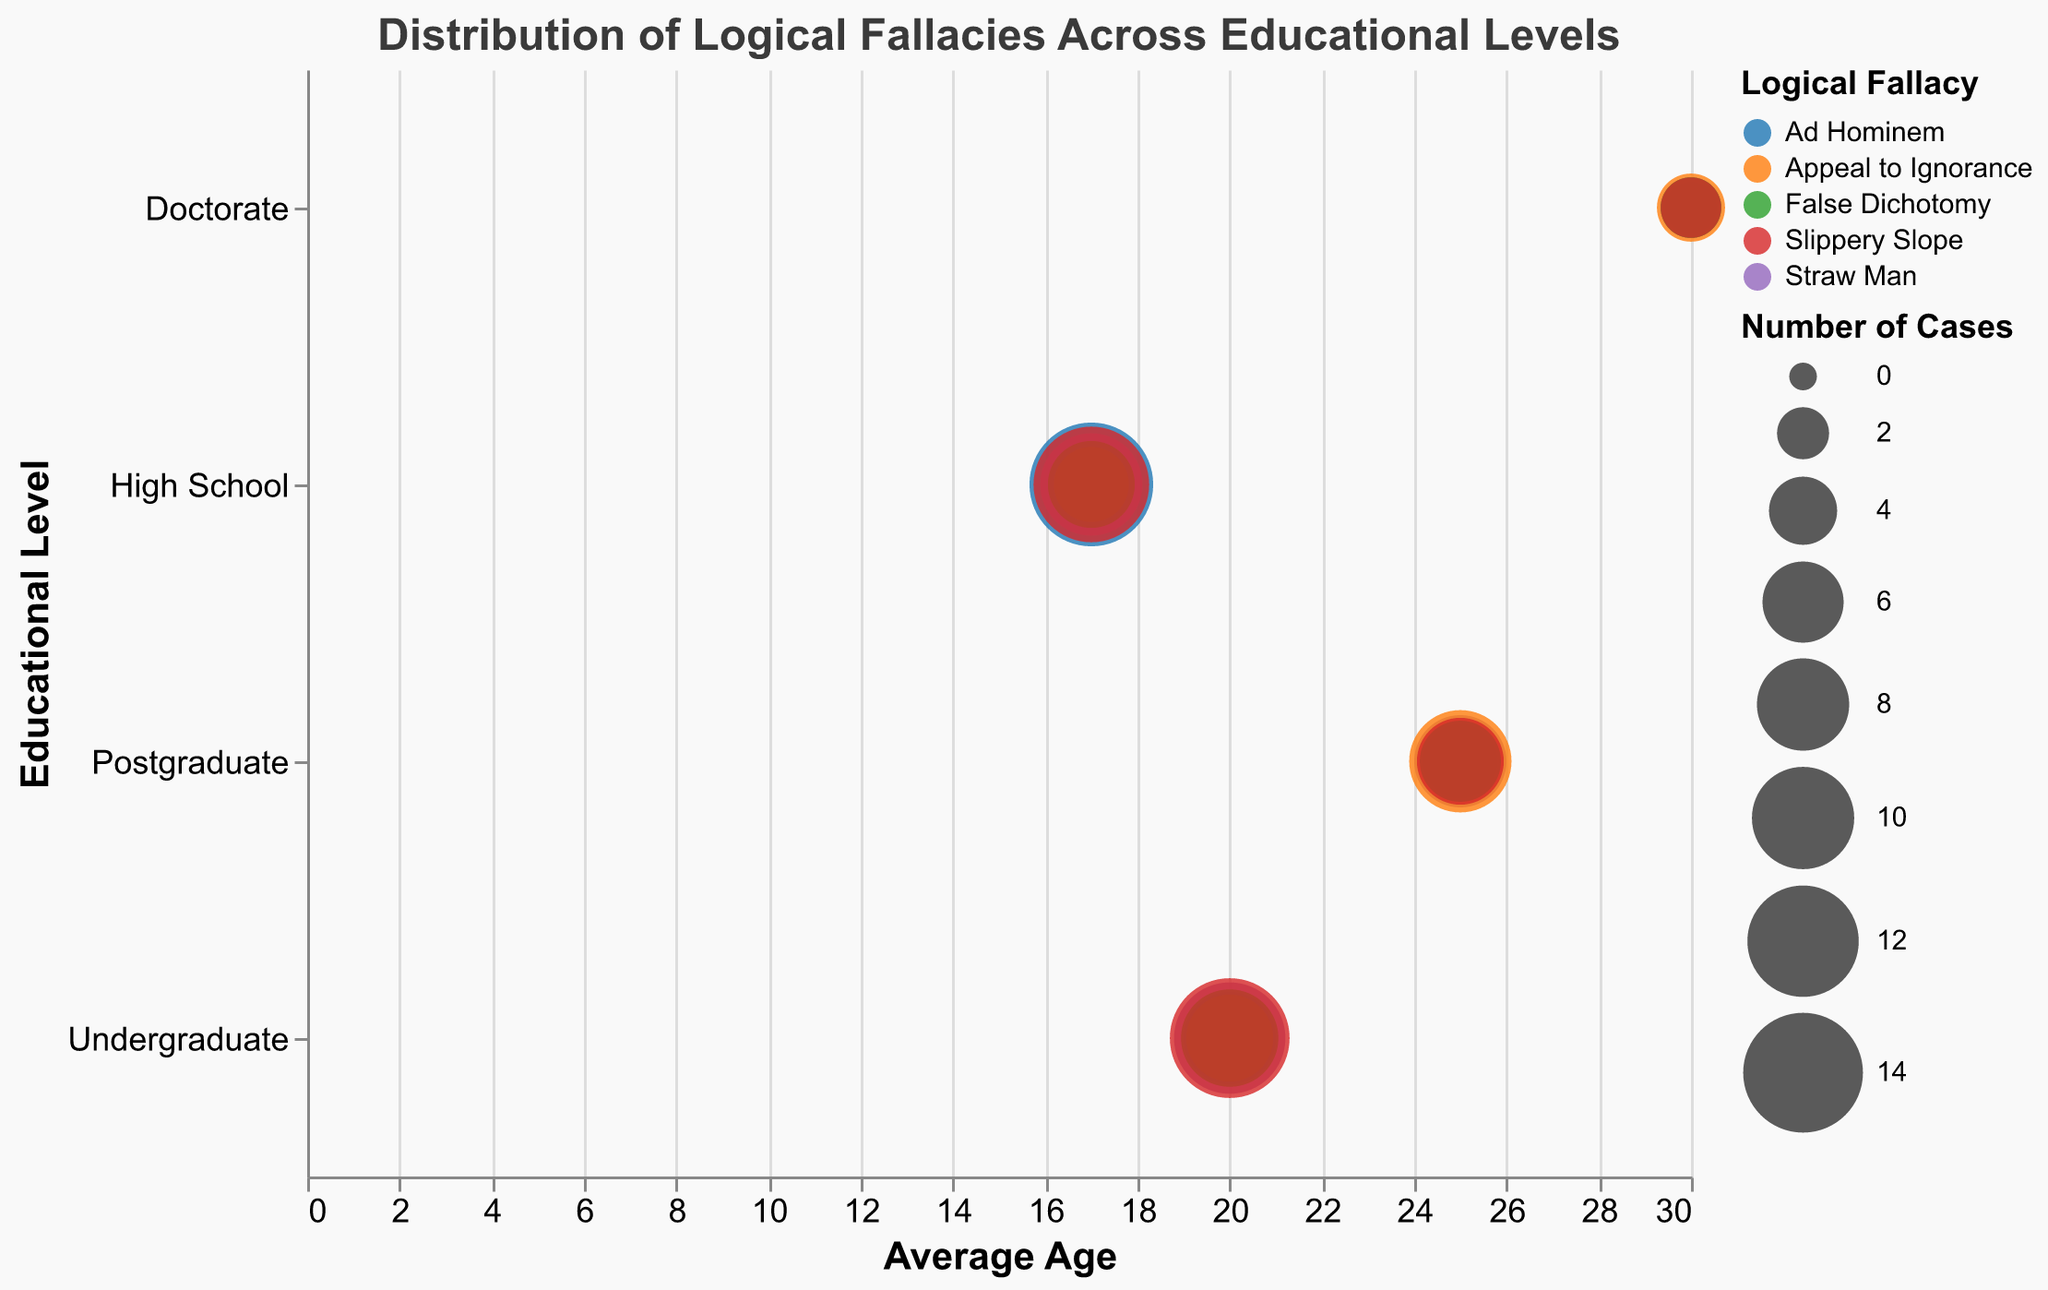What is the average age of individuals in the "Undergraduate" educational level category? The x-axis represents the average age. For the "Undergraduate" category, this is marked as 20.
Answer: 20 Which logical fallacy has the highest number of cases in the "High School" educational level? The size of the bubbles represents the number of cases, and bigger bubbles indicate a higher number. For the "High School" level, the largest bubble corresponds to the "Ad Hominem" fallacy with 15 cases.
Answer: Ad Hominem Compare the total number of cases of "False Dichotomy" and "Slippery Slope" fallacies across all educational levels. Which has more cases? Summing up the number of cases for each.
- False Dichotomy: 7(HS) + 9(UG) + 6(PG) + 3(D) = 25 
- Slippery Slope: 13(HS) + 14(UG) + 7(PG) + 3(D) = 37
"Slippery Slope" has more cases.
Answer: Slippery Slope What is the most frequent logical fallacy in the "Doctorate" educational level? For the "Doctorate" category, the largest bubble corresponds to "Appeal to Ignorance" with 4 cases.
Answer: Appeal to Ignorance How many different logical fallacies are represented in the chart? Each different color of the bubble represents a different logical fallacy. Count distinct colors. There are five: Ad Hominem, Straw Man, Appeal to Ignorance, False Dichotomy, Slippery Slope.
Answer: 5 Is there a trend in the number of "Ad Hominem" cases as the educational level increases? Observing the size of the bubbles corresponding to "Ad Hominem" across educational levels: HS = 15, UG = 8, PG = 5, D = 2. The number of cases decreases as the educational level increases.
Answer: Decrease What is the total number of logical fallacies cases for the "Postgraduate" educational level? Summing up the number of cases for different fallacies in the "Postgraduate" category: 5 + 8 + 10 + 6 + 7 = 36.
Answer: 36 Which educational level has the largest number of different logical fallacies? Counting distinct fallacies for each educational level:
- High School: 5
- Undergraduate: 5
- Postgraduate: 5
- Doctorate: 4
"High School," "Undergraduate," and "Postgraduate" each have the same and largest number of different logical fallacies at 5.
Answer: High School, Undergraduate, Postgraduate Comparing "Straw Man" fallacy, which educational level has the least number of cases? For "Straw Man":
- High School: 10
- Undergraduate: 12
- Postgraduate: 8
- Doctorate: 3
The "Doctorate" level has the least with 3 cases.
Answer: Doctorate What is the combined number of "Ad Hominem" and "Straw Man" fallacies at the "Postgraduate" level? Summing up the number of cases for both fallacies at "Postgraduate": Ad Hominem = 5, Straw Man = 8, so 5 + 8 = 13.
Answer: 13 